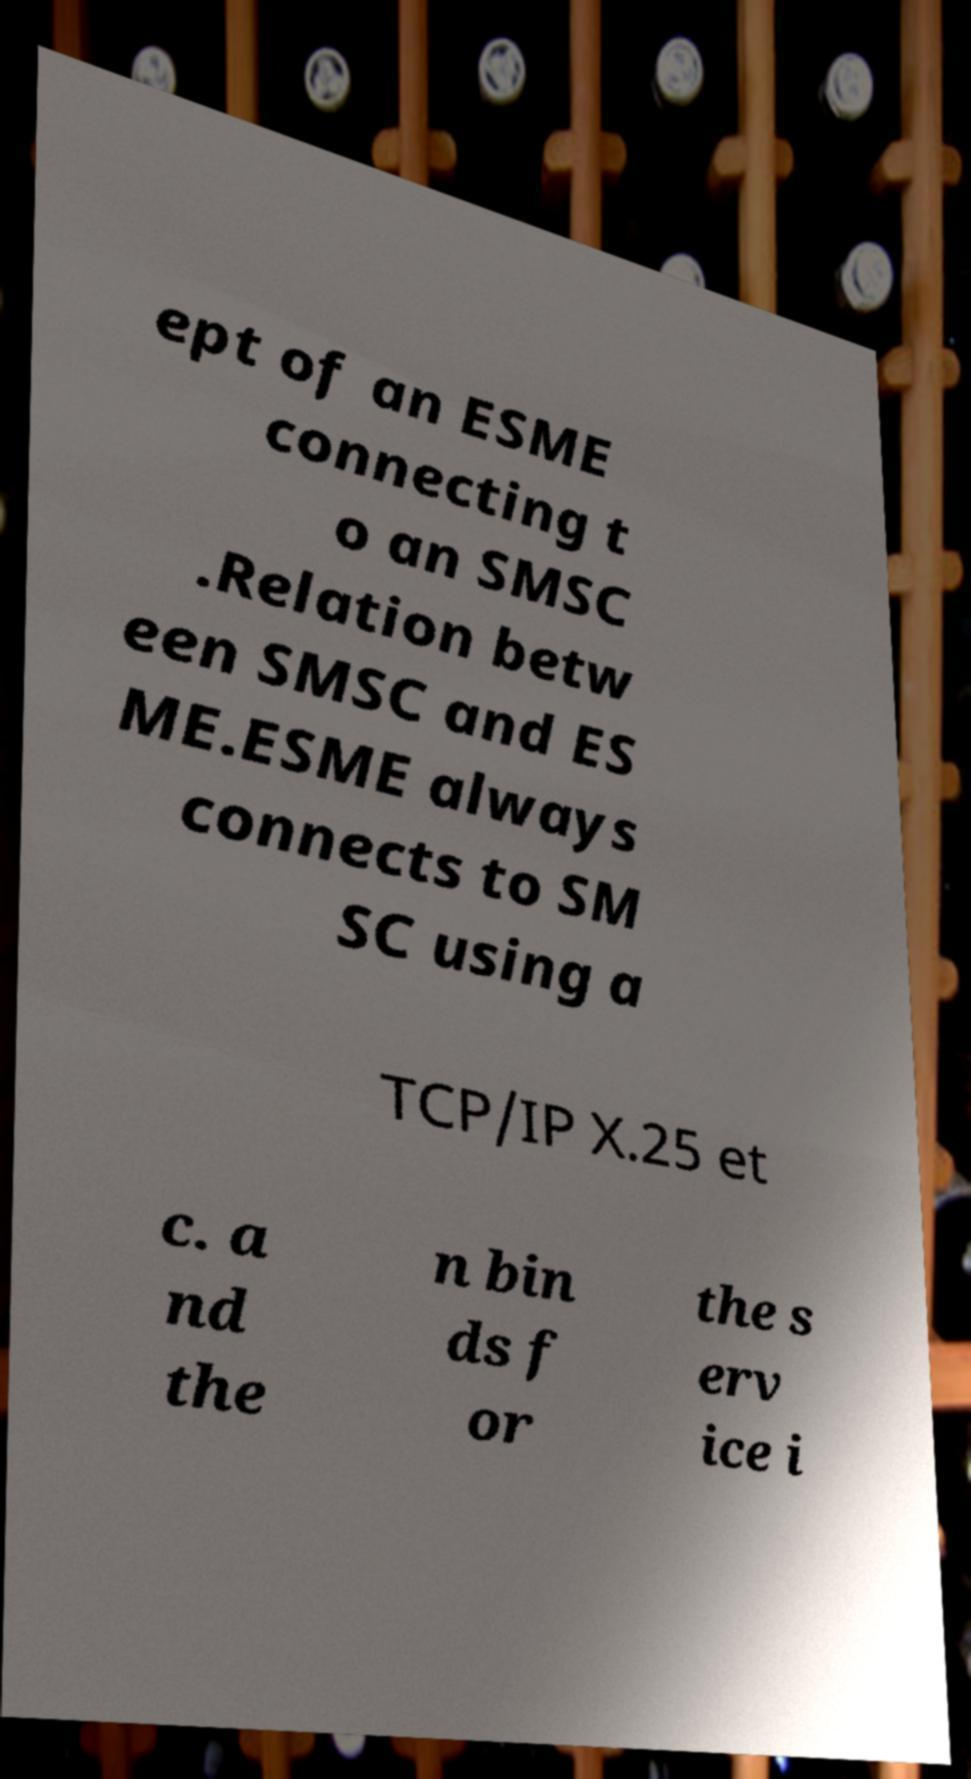Can you accurately transcribe the text from the provided image for me? ept of an ESME connecting t o an SMSC .Relation betw een SMSC and ES ME.ESME always connects to SM SC using a TCP/IP X.25 et c. a nd the n bin ds f or the s erv ice i 